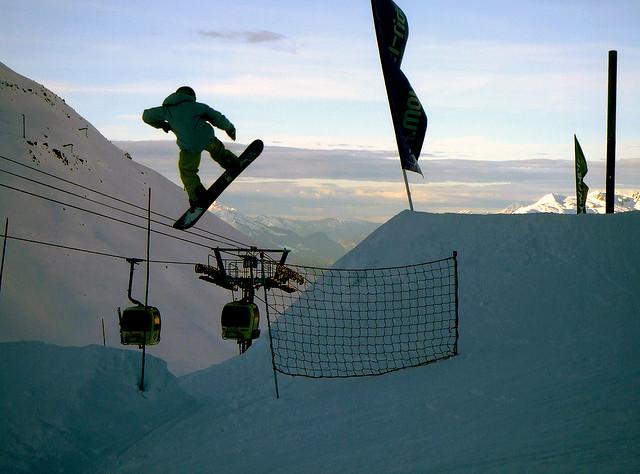What is the man skating on?
Keep it brief. Snow. How did the snowboarder end up in the air?
Quick response, please. Jump. What is under the man's feet?
Keep it brief. Snowboard. What is in the snow?
Be succinct. Net. Is the man in the air?
Write a very short answer. Yes. What is this person riding?
Give a very brief answer. Snowboard. What is on the cables by the side of the hill?
Be succinct. Gondola. 